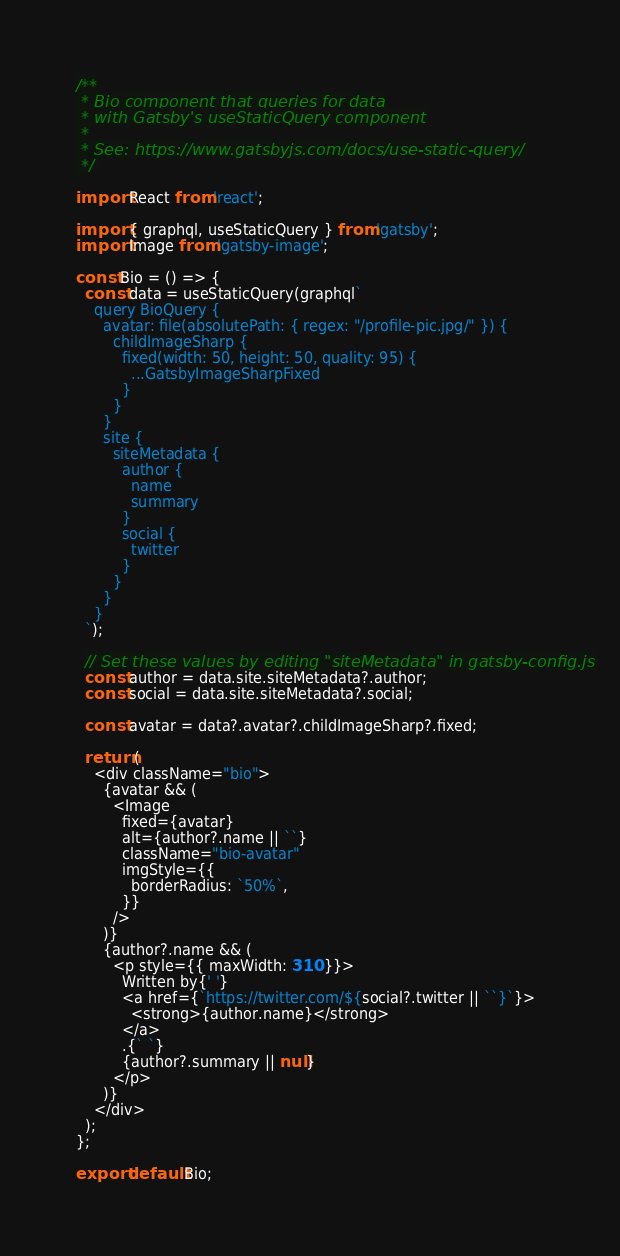Convert code to text. <code><loc_0><loc_0><loc_500><loc_500><_JavaScript_>/**
 * Bio component that queries for data
 * with Gatsby's useStaticQuery component
 *
 * See: https://www.gatsbyjs.com/docs/use-static-query/
 */

import React from 'react';

import { graphql, useStaticQuery } from 'gatsby';
import Image from 'gatsby-image';

const Bio = () => {
  const data = useStaticQuery(graphql`
    query BioQuery {
      avatar: file(absolutePath: { regex: "/profile-pic.jpg/" }) {
        childImageSharp {
          fixed(width: 50, height: 50, quality: 95) {
            ...GatsbyImageSharpFixed
          }
        }
      }
      site {
        siteMetadata {
          author {
            name
            summary
          }
          social {
            twitter
          }
        }
      }
    }
  `);

  // Set these values by editing "siteMetadata" in gatsby-config.js
  const author = data.site.siteMetadata?.author;
  const social = data.site.siteMetadata?.social;

  const avatar = data?.avatar?.childImageSharp?.fixed;

  return (
    <div className="bio">
      {avatar && (
        <Image
          fixed={avatar}
          alt={author?.name || ``}
          className="bio-avatar"
          imgStyle={{
            borderRadius: `50%`,
          }}
        />
      )}
      {author?.name && (
        <p style={{ maxWidth: 310 }}>
          Written by{' '}
          <a href={`https://twitter.com/${social?.twitter || ``}`}>
            <strong>{author.name}</strong>
          </a>
          .{` `}
          {author?.summary || null}
        </p>
      )}
    </div>
  );
};

export default Bio;
</code> 